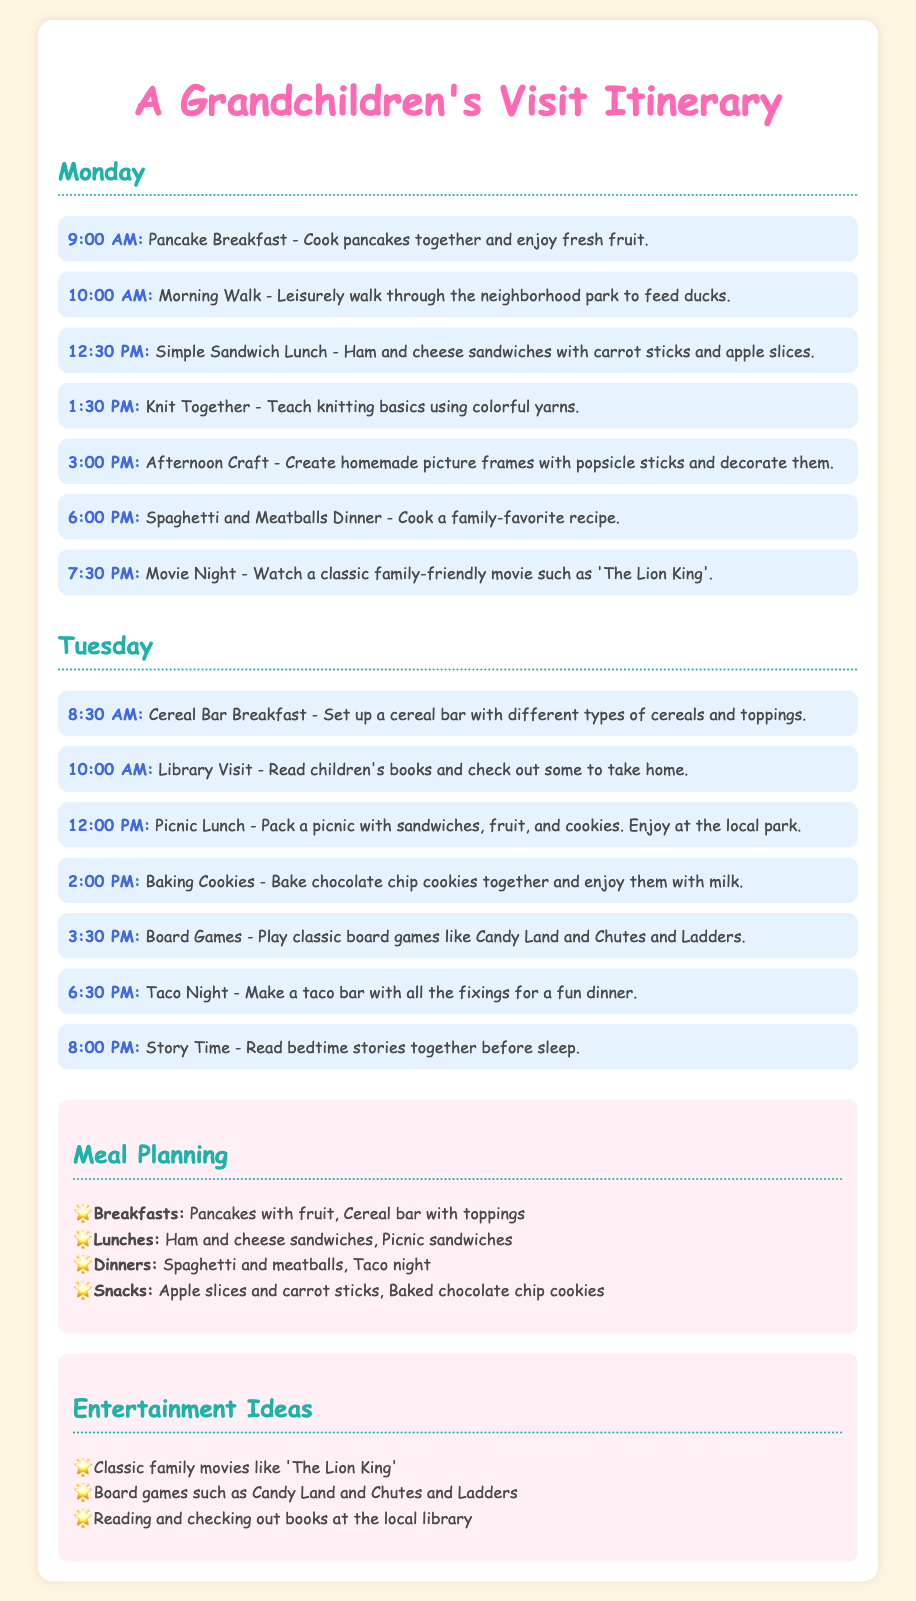What time is pancake breakfast scheduled? The time for pancake breakfast is specified in the document as 9:00 AM.
Answer: 9:00 AM What is the first activity on Tuesday? The first activity on Tuesday is a cereal bar breakfast scheduled at 8:30 AM.
Answer: Cereal Bar Breakfast What meal is planned for dinner on Monday? The document states that Spaghetti and Meatballs is the planned dinner for Monday.
Answer: Spaghetti and Meatballs Which activity uses colorful yarns? The activity that involves colorful yarns is the knitting session scheduled for 1:30 PM on Monday.
Answer: Knit Together What type of cookies are to be baked on Tuesday? The cookies to be baked on Tuesday are chocolate chip cookies, as mentioned in the Tuesday schedule.
Answer: Chocolate chip cookies 